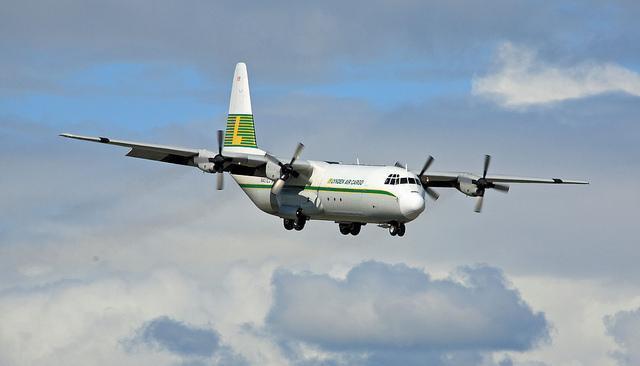How many propellers are there?
Give a very brief answer. 4. How many people are wearing caps?
Give a very brief answer. 0. 